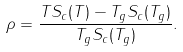<formula> <loc_0><loc_0><loc_500><loc_500>\rho = \frac { T S _ { c } ( T ) - T _ { g } S _ { c } ( T _ { g } ) } { T _ { g } S _ { c } ( T _ { g } ) } .</formula> 